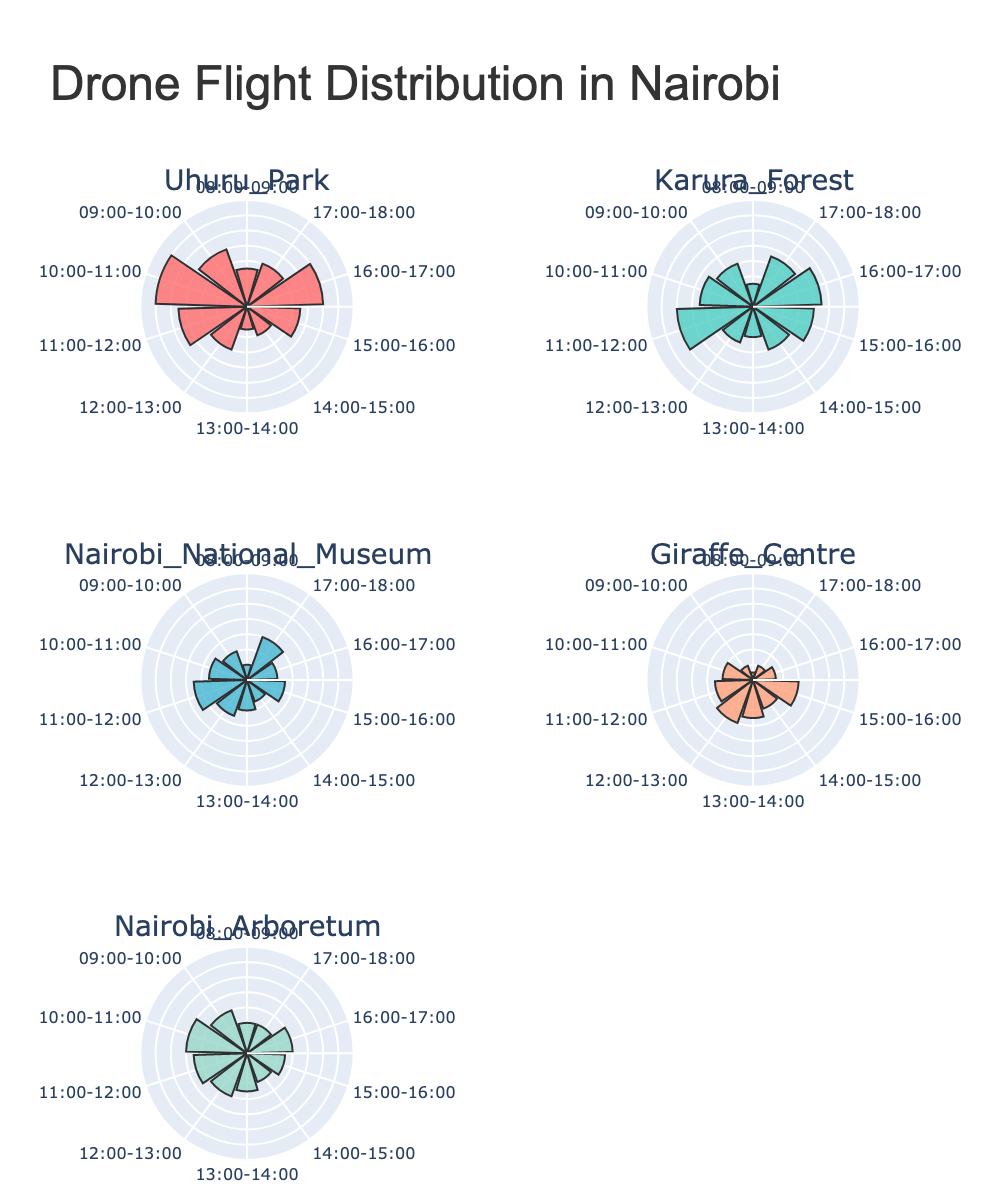How many drone flights were recorded in Uhuru Park between 10:00 and 11:00? Look at the subplot for Uhuru Park and find the bar labeled 10:00-11:00. The height indicates the number of flights, which is 12.
Answer: 12 Which location has the highest number of drone flights in any given hour? Compare the highest values of the bars in all subplots. The maximum height is observed in Uhuru Park for the hour 10:00-11:00, with 12 flights.
Answer: Uhuru Park During which hour does Karura Forest see the maximum number of drone flights? Check the Karura Forest subplot and find the hour with the tallest bar. The highest number of flights is at 16:00-17:00 with 9 flights.
Answer: 16:00-17:00 What is the total number of drone flights recorded at the Giraffe Centre? Sum the heights of all bars in the Giraffe Centre subplot: 1 + 2 + 4 + 5 + 6 + 5 + 4 + 6 + 3 + 2 = 38.
Answer: 38 Which location has the most consistent number of drone flights throughout the day? Compare the variations in the heights of bars across each hour for all locations. Nairobi Arboretum appears to have a more consistent distribution without extreme variations.
Answer: Nairobi Arboretum In which location is drone activity the lowest during the 08:00-09:00 hour? Compare the heights of the bars labeled 08:00-09:00 across all subplots. The lowest bar for this time slot is at Giraffe Centre with 1 flight.
Answer: Giraffe Centre How does the drone flight count at 12:00-13:00 in Nairobi National Museum compare to Karura Forest? Check the corresponding bars in the subplots for both locations. Nairobi National Museum has 5 flights while Karura Forest has 5 flights as well.
Answer: The same What is the total number of drone flights recorded in all locations combined for the hour 15:00-16:00? Sum the heights of the bars labeled 15:00-16:00 from all the subplots: 7 (Uhuru Park) + 8 (Karura Forest) + 5 (Nairobi National Museum) + 6 (Giraffe Centre) + 5 (Nairobi Arboretum) = 31.
Answer: 31 Which location shows a decreasing trend in drone flights from morning to evening? Identify locations where the bars decrease as you move clockwise from the start to the end of the day. The Giraffe Centre shows such a decreasing trend overall.
Answer: Giraffe Centre 